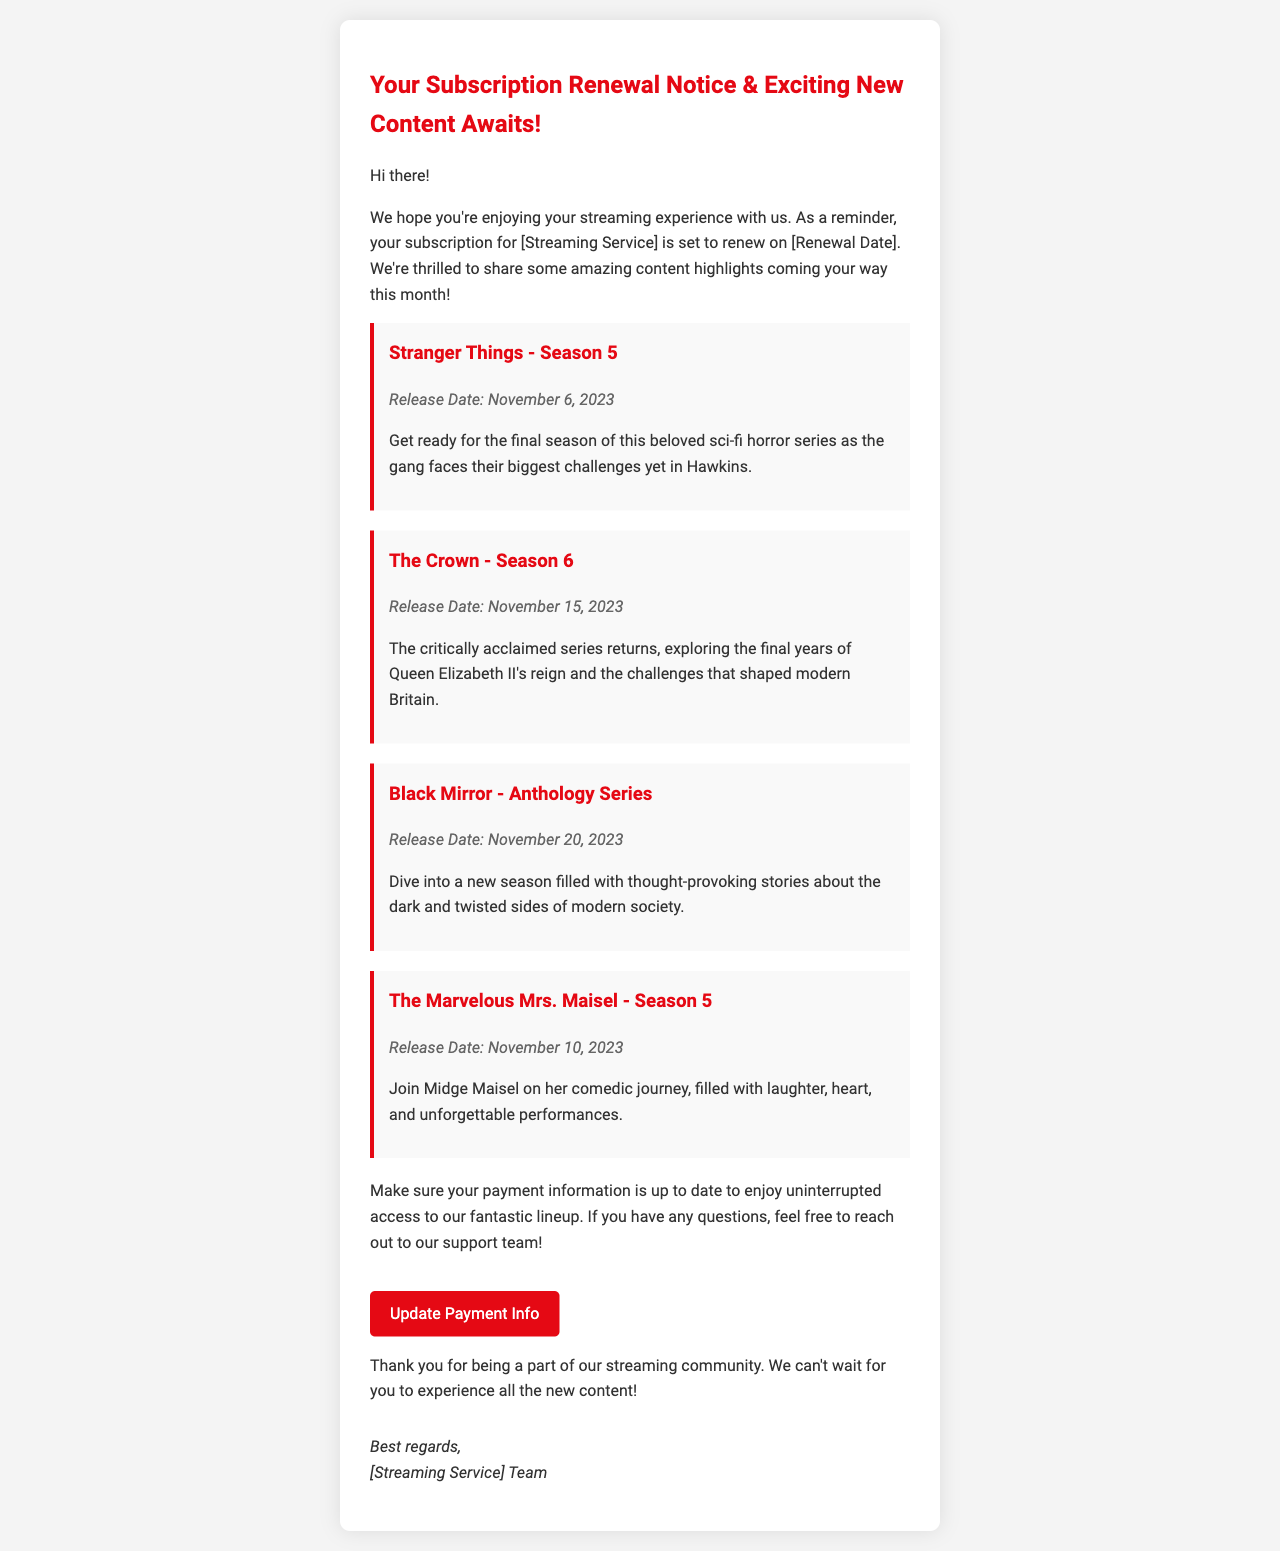What is the renewal date? The renewal date is explicitly mentioned in the email as [Renewal Date], indicating when the subscription will renew.
Answer: [Renewal Date] When is the release date for Stranger Things - Season 5? The document includes the release date for Stranger Things - Season 5, which is specified within the content highlights.
Answer: November 6, 2023 What series returns on November 15, 2023? The release of The Crown - Season 6 is highlighted with its specific release date, making this information retrieval straightforward.
Answer: The Crown - Season 6 How many seasons does The Marvelous Mrs. Maisel have? The email mentions that The Marvelous Mrs. Maisel - Season 5 is upcoming, implying there are at least five seasons of the series.
Answer: 5 What type of series is Black Mirror? The document describes Black Mirror as an anthology series, indicating its format and genre.
Answer: Anthology Series What should I do to ensure uninterrupted access? The email suggests updating payment information to prevent disruption to the streaming service, expressing a common requirement.
Answer: Update payment info Who is the email from? The document concludes with a signature that indicates the sender's identity linked to the streaming service, suggesting who is communicating this information.
Answer: [Streaming Service] Team What genre does Stranger Things belong to? The content highlight for Stranger Things specifies that it is a sci-fi horror series, clearly categorizing its genre.
Answer: Sci-fi horror What is the color of the call-to-action button? The call-to-action button for updating payment information has an identifiable color specified in the document's description.
Answer: Red 